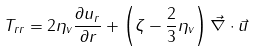Convert formula to latex. <formula><loc_0><loc_0><loc_500><loc_500>T _ { r r } = 2 \eta _ { v } \frac { \partial u _ { r } } { \partial r } + \left ( \zeta - \frac { 2 } { 3 } \eta _ { v } \right ) \vec { \nabla } \cdot \vec { u }</formula> 